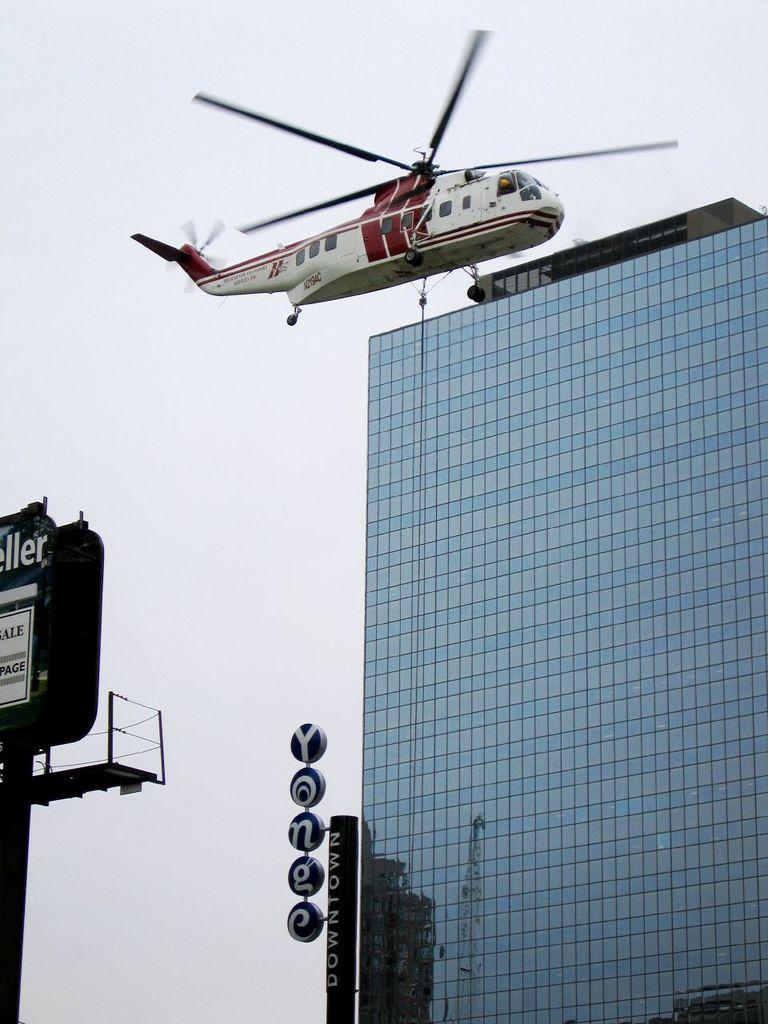What type of structure is present in the image? There is a building in the image. What objects are made of wood in the image? There are boards in the image. What is written on the boards? Something is written on the boards. What is the tall, thin object in the image? There is a pole in the image. What part of the natural environment is visible in the image? The sky is visible in the image. What type of vehicle is in the air in the image? There is a helicopter in the image, and it is in the air. What type of cloth is draped over the door in the image? There is no door or cloth present in the image. What type of field can be seen in the background of the image? There is no field visible in the image; it features a building, boards, a pole, and a helicopter. 